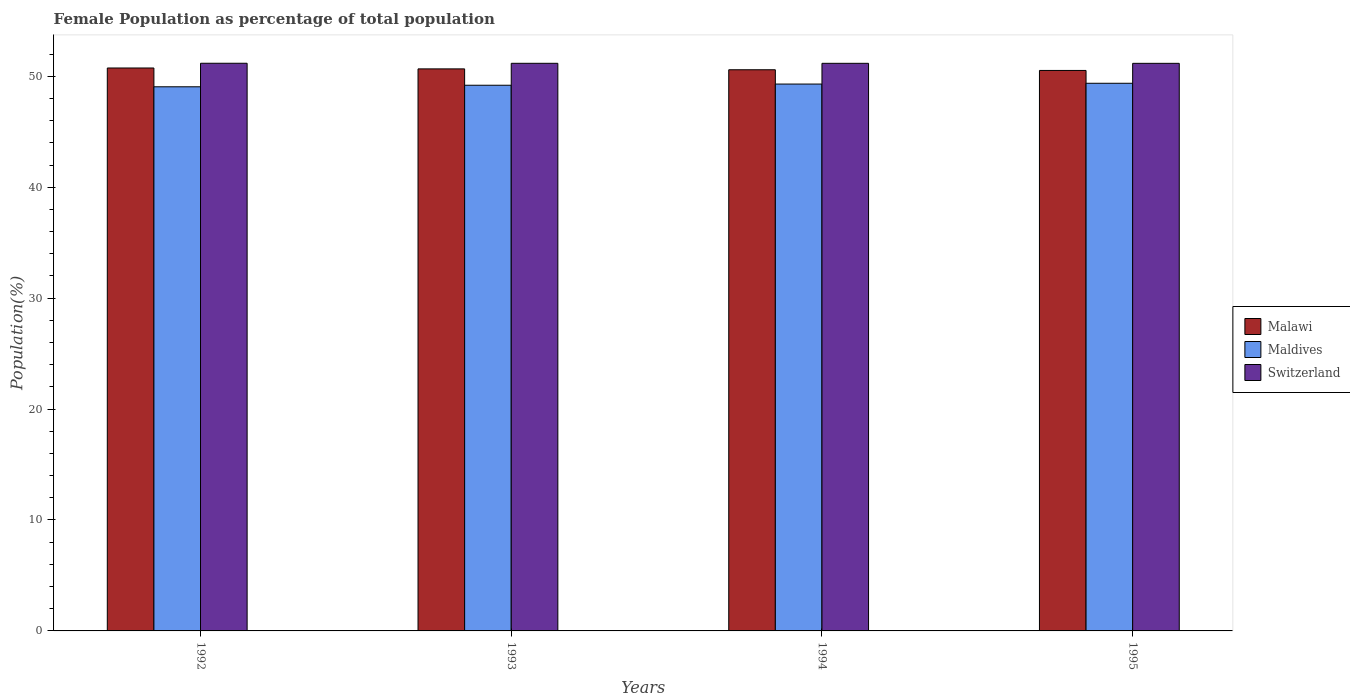How many different coloured bars are there?
Offer a terse response. 3. How many groups of bars are there?
Offer a terse response. 4. What is the female population in in Switzerland in 1992?
Keep it short and to the point. 51.17. Across all years, what is the maximum female population in in Maldives?
Give a very brief answer. 49.37. Across all years, what is the minimum female population in in Switzerland?
Offer a very short reply. 51.16. In which year was the female population in in Maldives minimum?
Your answer should be very brief. 1992. What is the total female population in in Malawi in the graph?
Offer a very short reply. 202.52. What is the difference between the female population in in Maldives in 1993 and that in 1995?
Provide a succinct answer. -0.18. What is the difference between the female population in in Malawi in 1992 and the female population in in Switzerland in 1994?
Keep it short and to the point. -0.42. What is the average female population in in Maldives per year?
Your answer should be very brief. 49.23. In the year 1993, what is the difference between the female population in in Maldives and female population in in Switzerland?
Provide a short and direct response. -1.98. What is the ratio of the female population in in Maldives in 1993 to that in 1995?
Keep it short and to the point. 1. Is the female population in in Switzerland in 1994 less than that in 1995?
Provide a succinct answer. No. Is the difference between the female population in in Maldives in 1993 and 1994 greater than the difference between the female population in in Switzerland in 1993 and 1994?
Offer a terse response. No. What is the difference between the highest and the second highest female population in in Malawi?
Keep it short and to the point. 0.08. What is the difference between the highest and the lowest female population in in Malawi?
Give a very brief answer. 0.22. Is the sum of the female population in in Switzerland in 1993 and 1995 greater than the maximum female population in in Maldives across all years?
Your answer should be compact. Yes. What does the 2nd bar from the left in 1993 represents?
Offer a terse response. Maldives. What does the 1st bar from the right in 1993 represents?
Give a very brief answer. Switzerland. Are all the bars in the graph horizontal?
Ensure brevity in your answer.  No. Are the values on the major ticks of Y-axis written in scientific E-notation?
Provide a succinct answer. No. Does the graph contain any zero values?
Provide a short and direct response. No. Does the graph contain grids?
Ensure brevity in your answer.  No. How many legend labels are there?
Make the answer very short. 3. What is the title of the graph?
Your answer should be very brief. Female Population as percentage of total population. What is the label or title of the X-axis?
Provide a succinct answer. Years. What is the label or title of the Y-axis?
Offer a terse response. Population(%). What is the Population(%) in Malawi in 1992?
Make the answer very short. 50.75. What is the Population(%) in Maldives in 1992?
Give a very brief answer. 49.05. What is the Population(%) of Switzerland in 1992?
Your answer should be very brief. 51.17. What is the Population(%) of Malawi in 1993?
Your answer should be very brief. 50.66. What is the Population(%) in Maldives in 1993?
Provide a succinct answer. 49.19. What is the Population(%) in Switzerland in 1993?
Make the answer very short. 51.17. What is the Population(%) of Malawi in 1994?
Your answer should be very brief. 50.59. What is the Population(%) in Maldives in 1994?
Provide a short and direct response. 49.3. What is the Population(%) of Switzerland in 1994?
Your answer should be compact. 51.17. What is the Population(%) in Malawi in 1995?
Provide a short and direct response. 50.52. What is the Population(%) in Maldives in 1995?
Your response must be concise. 49.37. What is the Population(%) in Switzerland in 1995?
Your response must be concise. 51.16. Across all years, what is the maximum Population(%) of Malawi?
Make the answer very short. 50.75. Across all years, what is the maximum Population(%) in Maldives?
Keep it short and to the point. 49.37. Across all years, what is the maximum Population(%) in Switzerland?
Your response must be concise. 51.17. Across all years, what is the minimum Population(%) in Malawi?
Keep it short and to the point. 50.52. Across all years, what is the minimum Population(%) of Maldives?
Keep it short and to the point. 49.05. Across all years, what is the minimum Population(%) of Switzerland?
Ensure brevity in your answer.  51.16. What is the total Population(%) in Malawi in the graph?
Make the answer very short. 202.52. What is the total Population(%) of Maldives in the graph?
Give a very brief answer. 196.91. What is the total Population(%) of Switzerland in the graph?
Your response must be concise. 204.67. What is the difference between the Population(%) in Malawi in 1992 and that in 1993?
Provide a succinct answer. 0.08. What is the difference between the Population(%) in Maldives in 1992 and that in 1993?
Ensure brevity in your answer.  -0.14. What is the difference between the Population(%) in Switzerland in 1992 and that in 1993?
Your response must be concise. 0. What is the difference between the Population(%) in Malawi in 1992 and that in 1994?
Provide a short and direct response. 0.16. What is the difference between the Population(%) in Maldives in 1992 and that in 1994?
Keep it short and to the point. -0.25. What is the difference between the Population(%) in Switzerland in 1992 and that in 1994?
Your answer should be compact. 0.01. What is the difference between the Population(%) of Malawi in 1992 and that in 1995?
Offer a terse response. 0.22. What is the difference between the Population(%) of Maldives in 1992 and that in 1995?
Offer a very short reply. -0.32. What is the difference between the Population(%) of Switzerland in 1992 and that in 1995?
Keep it short and to the point. 0.01. What is the difference between the Population(%) of Malawi in 1993 and that in 1994?
Your response must be concise. 0.08. What is the difference between the Population(%) in Maldives in 1993 and that in 1994?
Your response must be concise. -0.11. What is the difference between the Population(%) in Switzerland in 1993 and that in 1994?
Provide a short and direct response. 0. What is the difference between the Population(%) in Malawi in 1993 and that in 1995?
Your answer should be compact. 0.14. What is the difference between the Population(%) of Maldives in 1993 and that in 1995?
Your response must be concise. -0.18. What is the difference between the Population(%) of Switzerland in 1993 and that in 1995?
Provide a succinct answer. 0. What is the difference between the Population(%) of Malawi in 1994 and that in 1995?
Your answer should be very brief. 0.06. What is the difference between the Population(%) in Maldives in 1994 and that in 1995?
Keep it short and to the point. -0.07. What is the difference between the Population(%) in Switzerland in 1994 and that in 1995?
Your answer should be compact. 0. What is the difference between the Population(%) in Malawi in 1992 and the Population(%) in Maldives in 1993?
Ensure brevity in your answer.  1.56. What is the difference between the Population(%) of Malawi in 1992 and the Population(%) of Switzerland in 1993?
Ensure brevity in your answer.  -0.42. What is the difference between the Population(%) in Maldives in 1992 and the Population(%) in Switzerland in 1993?
Provide a short and direct response. -2.12. What is the difference between the Population(%) of Malawi in 1992 and the Population(%) of Maldives in 1994?
Ensure brevity in your answer.  1.45. What is the difference between the Population(%) of Malawi in 1992 and the Population(%) of Switzerland in 1994?
Provide a succinct answer. -0.42. What is the difference between the Population(%) of Maldives in 1992 and the Population(%) of Switzerland in 1994?
Your response must be concise. -2.11. What is the difference between the Population(%) in Malawi in 1992 and the Population(%) in Maldives in 1995?
Ensure brevity in your answer.  1.38. What is the difference between the Population(%) of Malawi in 1992 and the Population(%) of Switzerland in 1995?
Give a very brief answer. -0.42. What is the difference between the Population(%) in Maldives in 1992 and the Population(%) in Switzerland in 1995?
Ensure brevity in your answer.  -2.11. What is the difference between the Population(%) of Malawi in 1993 and the Population(%) of Maldives in 1994?
Offer a very short reply. 1.37. What is the difference between the Population(%) of Malawi in 1993 and the Population(%) of Switzerland in 1994?
Ensure brevity in your answer.  -0.5. What is the difference between the Population(%) of Maldives in 1993 and the Population(%) of Switzerland in 1994?
Keep it short and to the point. -1.98. What is the difference between the Population(%) in Malawi in 1993 and the Population(%) in Maldives in 1995?
Your response must be concise. 1.3. What is the difference between the Population(%) in Malawi in 1993 and the Population(%) in Switzerland in 1995?
Provide a succinct answer. -0.5. What is the difference between the Population(%) of Maldives in 1993 and the Population(%) of Switzerland in 1995?
Give a very brief answer. -1.97. What is the difference between the Population(%) of Malawi in 1994 and the Population(%) of Maldives in 1995?
Make the answer very short. 1.22. What is the difference between the Population(%) of Malawi in 1994 and the Population(%) of Switzerland in 1995?
Your response must be concise. -0.58. What is the difference between the Population(%) in Maldives in 1994 and the Population(%) in Switzerland in 1995?
Offer a terse response. -1.87. What is the average Population(%) of Malawi per year?
Keep it short and to the point. 50.63. What is the average Population(%) of Maldives per year?
Offer a terse response. 49.23. What is the average Population(%) in Switzerland per year?
Your answer should be compact. 51.17. In the year 1992, what is the difference between the Population(%) in Malawi and Population(%) in Maldives?
Offer a terse response. 1.69. In the year 1992, what is the difference between the Population(%) of Malawi and Population(%) of Switzerland?
Your answer should be compact. -0.43. In the year 1992, what is the difference between the Population(%) of Maldives and Population(%) of Switzerland?
Your answer should be compact. -2.12. In the year 1993, what is the difference between the Population(%) in Malawi and Population(%) in Maldives?
Your answer should be very brief. 1.47. In the year 1993, what is the difference between the Population(%) in Malawi and Population(%) in Switzerland?
Your answer should be very brief. -0.5. In the year 1993, what is the difference between the Population(%) in Maldives and Population(%) in Switzerland?
Give a very brief answer. -1.98. In the year 1994, what is the difference between the Population(%) in Malawi and Population(%) in Maldives?
Provide a succinct answer. 1.29. In the year 1994, what is the difference between the Population(%) of Malawi and Population(%) of Switzerland?
Offer a very short reply. -0.58. In the year 1994, what is the difference between the Population(%) of Maldives and Population(%) of Switzerland?
Ensure brevity in your answer.  -1.87. In the year 1995, what is the difference between the Population(%) in Malawi and Population(%) in Maldives?
Give a very brief answer. 1.16. In the year 1995, what is the difference between the Population(%) of Malawi and Population(%) of Switzerland?
Keep it short and to the point. -0.64. In the year 1995, what is the difference between the Population(%) of Maldives and Population(%) of Switzerland?
Offer a terse response. -1.8. What is the ratio of the Population(%) of Malawi in 1992 to that in 1993?
Keep it short and to the point. 1. What is the ratio of the Population(%) of Maldives in 1992 to that in 1993?
Ensure brevity in your answer.  1. What is the ratio of the Population(%) of Malawi in 1992 to that in 1995?
Provide a succinct answer. 1. What is the ratio of the Population(%) of Malawi in 1993 to that in 1994?
Ensure brevity in your answer.  1. What is the ratio of the Population(%) in Maldives in 1993 to that in 1994?
Make the answer very short. 1. What is the ratio of the Population(%) of Switzerland in 1993 to that in 1994?
Your answer should be compact. 1. What is the ratio of the Population(%) in Switzerland in 1993 to that in 1995?
Provide a short and direct response. 1. What is the ratio of the Population(%) of Switzerland in 1994 to that in 1995?
Ensure brevity in your answer.  1. What is the difference between the highest and the second highest Population(%) in Malawi?
Keep it short and to the point. 0.08. What is the difference between the highest and the second highest Population(%) of Maldives?
Your answer should be compact. 0.07. What is the difference between the highest and the second highest Population(%) in Switzerland?
Provide a succinct answer. 0. What is the difference between the highest and the lowest Population(%) of Malawi?
Provide a succinct answer. 0.22. What is the difference between the highest and the lowest Population(%) in Maldives?
Your response must be concise. 0.32. What is the difference between the highest and the lowest Population(%) in Switzerland?
Ensure brevity in your answer.  0.01. 